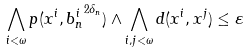Convert formula to latex. <formula><loc_0><loc_0><loc_500><loc_500>\bigwedge _ { i < \omega } p ( x ^ { i } , { b _ { n } ^ { i } } ^ { 2 \delta _ { n } } ) \land \bigwedge _ { i , j < \omega } d ( x ^ { i } , x ^ { j } ) \leq \varepsilon</formula> 